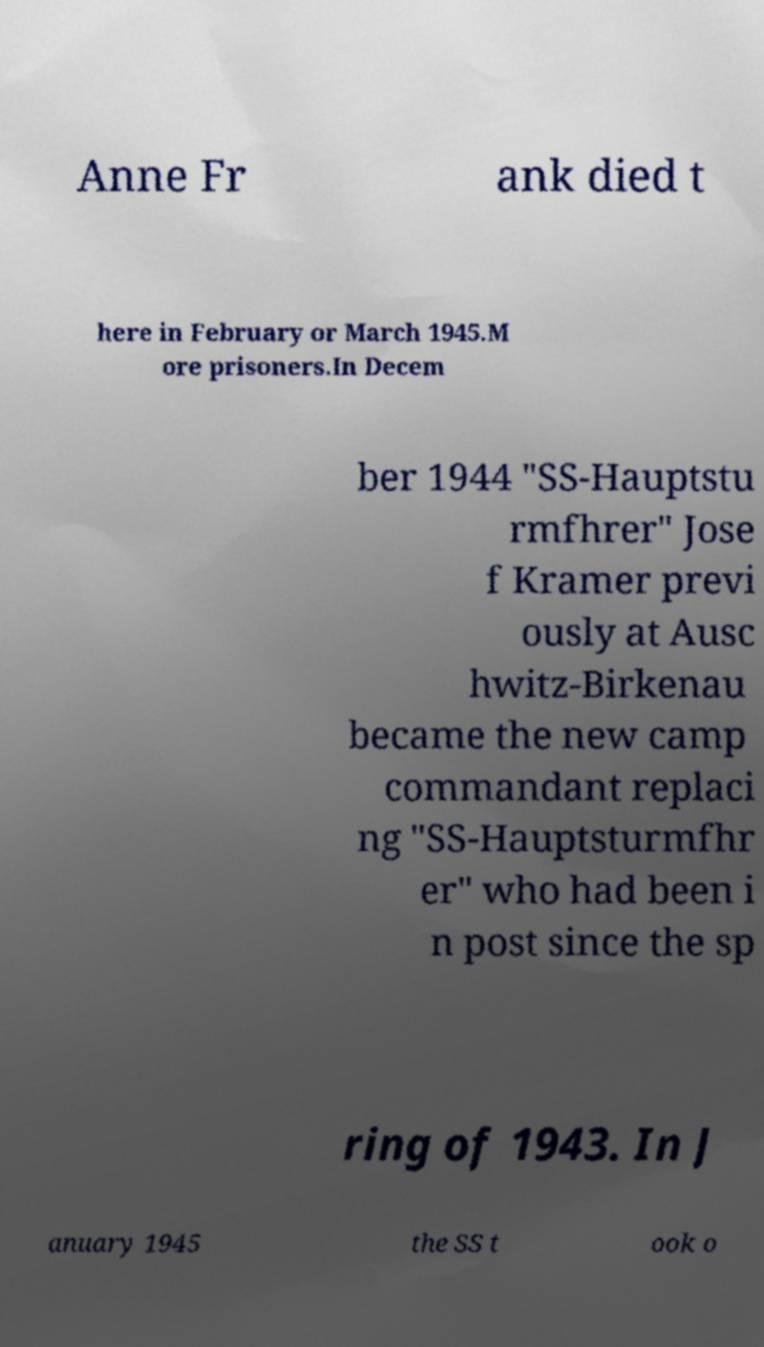Can you read and provide the text displayed in the image?This photo seems to have some interesting text. Can you extract and type it out for me? Anne Fr ank died t here in February or March 1945.M ore prisoners.In Decem ber 1944 "SS-Hauptstu rmfhrer" Jose f Kramer previ ously at Ausc hwitz-Birkenau became the new camp commandant replaci ng "SS-Hauptsturmfhr er" who had been i n post since the sp ring of 1943. In J anuary 1945 the SS t ook o 